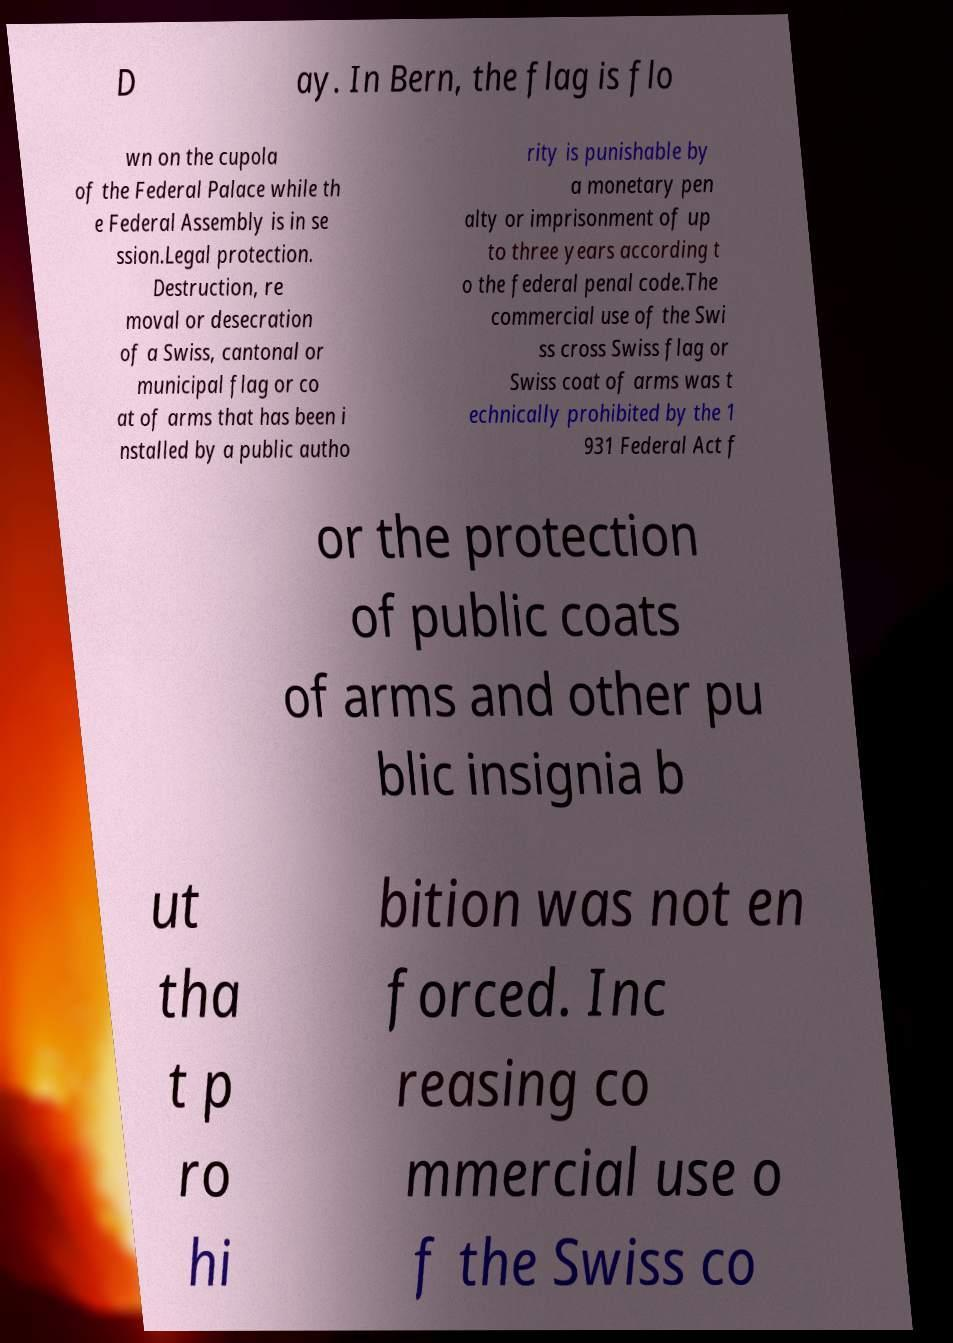I need the written content from this picture converted into text. Can you do that? D ay. In Bern, the flag is flo wn on the cupola of the Federal Palace while th e Federal Assembly is in se ssion.Legal protection. Destruction, re moval or desecration of a Swiss, cantonal or municipal flag or co at of arms that has been i nstalled by a public autho rity is punishable by a monetary pen alty or imprisonment of up to three years according t o the federal penal code.The commercial use of the Swi ss cross Swiss flag or Swiss coat of arms was t echnically prohibited by the 1 931 Federal Act f or the protection of public coats of arms and other pu blic insignia b ut tha t p ro hi bition was not en forced. Inc reasing co mmercial use o f the Swiss co 